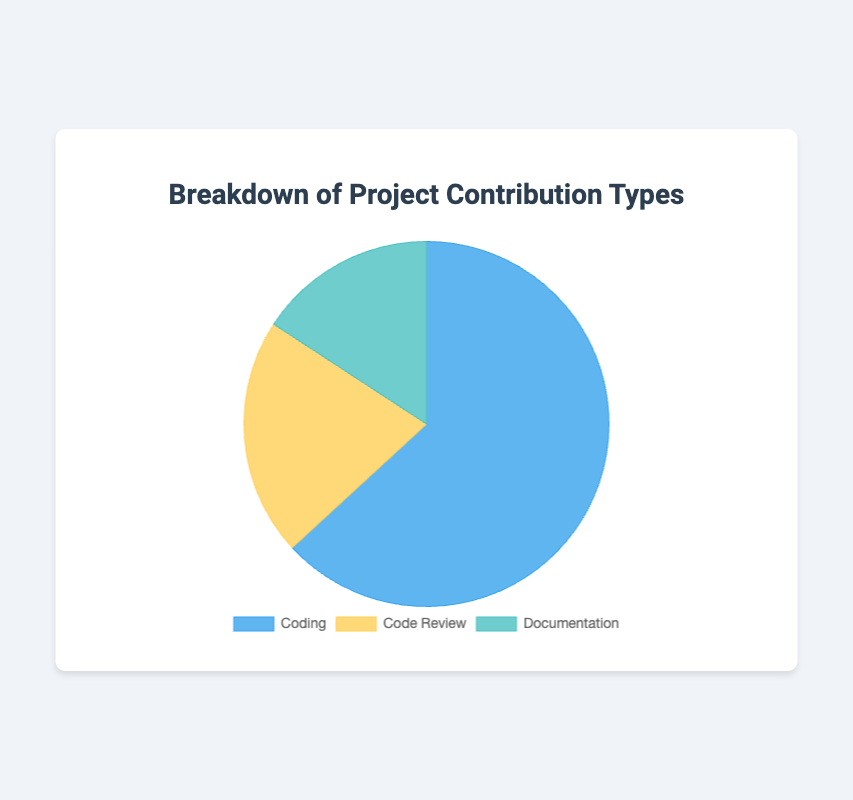Which contribution type occupies the largest section of the pie chart? The pie chart shows three contribution types: Coding, Code Review, and Documentation. The largest section is represented by Coding, indicating it has the highest proportion.
Answer: Coding Which contribution type occupies the smallest section of the pie chart? The smallest section of the pie chart represents Documentation, which indicates it has the lowest proportion among the three types.
Answer: Documentation What is the difference in percentage between Coding and Code Review? From the pie chart, Coding accounts for 60% and Code Review accounts for 20%. The difference is 60% - 20% = 40%.
Answer: 40% How many total hours were spent on Documentation? The data shows that 3 contributors spent a total of 100 hours on Documentation. The pie chart represents this as 15%. Therefore, Documentation accounts for 100 hours of the total project time.
Answer: 100 If you combine Code Review and Documentation, what percentage of the pie chart do they occupy together? Code Review occupies 20% of the chart, and Documentation occupies 15%. Summing these gives 20% + 15% = 35%.
Answer: 35% How do the colors of Coding and Documentation sections compare? The Coding section is represented by a blue color, while the Documentation section is represented by a green color. This visual difference helps identify them apart in the chart.
Answer: Coding is blue, Documentation is green What is the combined number of contributors for all contribution types shown in the pie chart? According to the data, there are 10 contributors for Coding, 4 for Code Review, and 3 for Documentation. The combined total is 10 + 4 + 3 = 17 contributors.
Answer: 17 What is the ratio of hours spent between Coding and Code Review? The data shows Coding has 400 hours spent and Code Review has 150 hours spent. The ratio is 400:150, which simplifies to approximately 8:3.
Answer: 8:3 Considering only the contribution types, what is the average estimated completion percentage? The estimated completion percentages for Coding, Code Review, and Documentation are 60%, 20%, and 15%, respectively. The average is calculated by (60% + 20% + 15%) / 3 = 31.67%.
Answer: 31.67% 